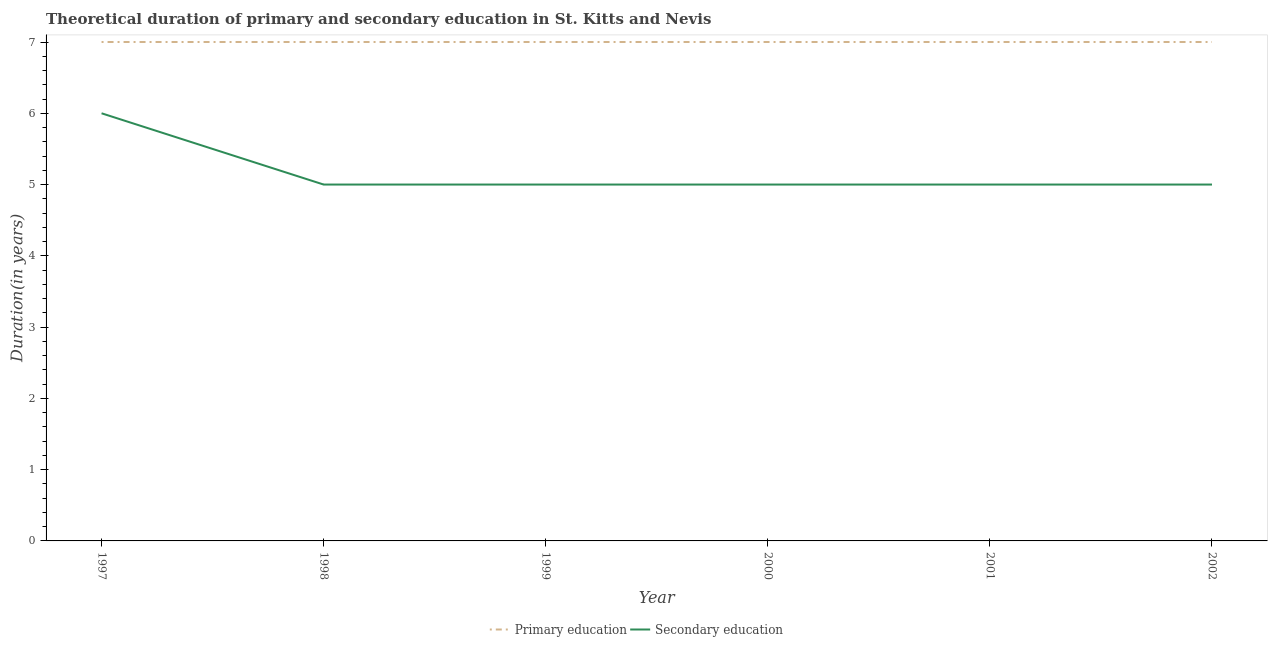Is the number of lines equal to the number of legend labels?
Provide a short and direct response. Yes. What is the duration of primary education in 1998?
Your answer should be compact. 7. Across all years, what is the minimum duration of primary education?
Ensure brevity in your answer.  7. In which year was the duration of primary education maximum?
Your answer should be compact. 1997. In which year was the duration of secondary education minimum?
Keep it short and to the point. 1998. What is the total duration of secondary education in the graph?
Provide a succinct answer. 31. What is the difference between the duration of secondary education in 1997 and that in 2001?
Your response must be concise. 1. What is the difference between the duration of primary education in 2001 and the duration of secondary education in 1999?
Your answer should be compact. 2. What is the average duration of primary education per year?
Provide a succinct answer. 7. In the year 2002, what is the difference between the duration of secondary education and duration of primary education?
Make the answer very short. -2. What is the ratio of the duration of primary education in 1999 to that in 2001?
Make the answer very short. 1. Is the difference between the duration of primary education in 1997 and 1999 greater than the difference between the duration of secondary education in 1997 and 1999?
Your response must be concise. No. What is the difference between the highest and the lowest duration of secondary education?
Offer a very short reply. 1. In how many years, is the duration of primary education greater than the average duration of primary education taken over all years?
Provide a succinct answer. 0. Does the duration of secondary education monotonically increase over the years?
Your answer should be compact. No. Is the duration of secondary education strictly greater than the duration of primary education over the years?
Ensure brevity in your answer.  No. Is the duration of primary education strictly less than the duration of secondary education over the years?
Give a very brief answer. No. How many years are there in the graph?
Make the answer very short. 6. What is the difference between two consecutive major ticks on the Y-axis?
Your answer should be very brief. 1. Are the values on the major ticks of Y-axis written in scientific E-notation?
Give a very brief answer. No. Does the graph contain any zero values?
Provide a succinct answer. No. Does the graph contain grids?
Keep it short and to the point. No. Where does the legend appear in the graph?
Give a very brief answer. Bottom center. How many legend labels are there?
Provide a short and direct response. 2. What is the title of the graph?
Provide a succinct answer. Theoretical duration of primary and secondary education in St. Kitts and Nevis. Does "Canada" appear as one of the legend labels in the graph?
Your answer should be very brief. No. What is the label or title of the Y-axis?
Ensure brevity in your answer.  Duration(in years). What is the Duration(in years) in Primary education in 1997?
Give a very brief answer. 7. What is the Duration(in years) in Primary education in 1998?
Make the answer very short. 7. What is the Duration(in years) of Secondary education in 1999?
Offer a terse response. 5. What is the Duration(in years) of Primary education in 2000?
Make the answer very short. 7. What is the Duration(in years) in Secondary education in 2000?
Ensure brevity in your answer.  5. What is the Duration(in years) in Secondary education in 2001?
Make the answer very short. 5. What is the Duration(in years) in Primary education in 2002?
Your response must be concise. 7. Across all years, what is the maximum Duration(in years) of Primary education?
Offer a terse response. 7. Across all years, what is the maximum Duration(in years) of Secondary education?
Make the answer very short. 6. Across all years, what is the minimum Duration(in years) in Primary education?
Give a very brief answer. 7. What is the total Duration(in years) in Primary education in the graph?
Ensure brevity in your answer.  42. What is the difference between the Duration(in years) of Primary education in 1997 and that in 1998?
Give a very brief answer. 0. What is the difference between the Duration(in years) in Secondary education in 1997 and that in 1998?
Give a very brief answer. 1. What is the difference between the Duration(in years) of Secondary education in 1997 and that in 1999?
Your answer should be very brief. 1. What is the difference between the Duration(in years) of Primary education in 1997 and that in 2000?
Provide a short and direct response. 0. What is the difference between the Duration(in years) in Secondary education in 1997 and that in 2001?
Your response must be concise. 1. What is the difference between the Duration(in years) of Primary education in 1997 and that in 2002?
Make the answer very short. 0. What is the difference between the Duration(in years) of Secondary education in 1997 and that in 2002?
Make the answer very short. 1. What is the difference between the Duration(in years) in Primary education in 1998 and that in 1999?
Offer a terse response. 0. What is the difference between the Duration(in years) of Primary education in 1998 and that in 2000?
Keep it short and to the point. 0. What is the difference between the Duration(in years) of Secondary education in 1998 and that in 2000?
Keep it short and to the point. 0. What is the difference between the Duration(in years) in Secondary education in 1999 and that in 2000?
Give a very brief answer. 0. What is the difference between the Duration(in years) of Secondary education in 1999 and that in 2001?
Provide a succinct answer. 0. What is the difference between the Duration(in years) in Primary education in 1999 and that in 2002?
Keep it short and to the point. 0. What is the difference between the Duration(in years) in Secondary education in 1999 and that in 2002?
Make the answer very short. 0. What is the difference between the Duration(in years) in Secondary education in 2000 and that in 2002?
Your answer should be very brief. 0. What is the difference between the Duration(in years) of Primary education in 2001 and that in 2002?
Provide a succinct answer. 0. What is the difference between the Duration(in years) of Secondary education in 2001 and that in 2002?
Keep it short and to the point. 0. What is the difference between the Duration(in years) in Primary education in 1997 and the Duration(in years) in Secondary education in 1999?
Provide a short and direct response. 2. What is the difference between the Duration(in years) of Primary education in 1997 and the Duration(in years) of Secondary education in 2000?
Provide a short and direct response. 2. What is the difference between the Duration(in years) in Primary education in 1998 and the Duration(in years) in Secondary education in 1999?
Offer a terse response. 2. What is the difference between the Duration(in years) of Primary education in 1998 and the Duration(in years) of Secondary education in 2001?
Make the answer very short. 2. What is the difference between the Duration(in years) in Primary education in 1998 and the Duration(in years) in Secondary education in 2002?
Your answer should be very brief. 2. What is the difference between the Duration(in years) in Primary education in 1999 and the Duration(in years) in Secondary education in 2000?
Keep it short and to the point. 2. What is the difference between the Duration(in years) of Primary education in 1999 and the Duration(in years) of Secondary education in 2001?
Offer a very short reply. 2. What is the difference between the Duration(in years) in Primary education in 2001 and the Duration(in years) in Secondary education in 2002?
Give a very brief answer. 2. What is the average Duration(in years) of Primary education per year?
Provide a succinct answer. 7. What is the average Duration(in years) of Secondary education per year?
Your answer should be compact. 5.17. In the year 1997, what is the difference between the Duration(in years) of Primary education and Duration(in years) of Secondary education?
Ensure brevity in your answer.  1. In the year 1998, what is the difference between the Duration(in years) in Primary education and Duration(in years) in Secondary education?
Keep it short and to the point. 2. In the year 1999, what is the difference between the Duration(in years) of Primary education and Duration(in years) of Secondary education?
Make the answer very short. 2. In the year 2002, what is the difference between the Duration(in years) in Primary education and Duration(in years) in Secondary education?
Offer a very short reply. 2. What is the ratio of the Duration(in years) of Primary education in 1997 to that in 1999?
Your answer should be very brief. 1. What is the ratio of the Duration(in years) of Primary education in 1997 to that in 2000?
Your response must be concise. 1. What is the ratio of the Duration(in years) in Secondary education in 1997 to that in 2000?
Keep it short and to the point. 1.2. What is the ratio of the Duration(in years) in Secondary education in 1997 to that in 2001?
Give a very brief answer. 1.2. What is the ratio of the Duration(in years) in Primary education in 1997 to that in 2002?
Your answer should be compact. 1. What is the ratio of the Duration(in years) in Secondary education in 1998 to that in 2002?
Your answer should be very brief. 1. What is the ratio of the Duration(in years) of Primary education in 1999 to that in 2001?
Ensure brevity in your answer.  1. What is the ratio of the Duration(in years) of Primary education in 2000 to that in 2001?
Keep it short and to the point. 1. What is the ratio of the Duration(in years) in Secondary education in 2000 to that in 2001?
Provide a succinct answer. 1. What is the difference between the highest and the second highest Duration(in years) in Secondary education?
Your response must be concise. 1. What is the difference between the highest and the lowest Duration(in years) of Primary education?
Your answer should be compact. 0. What is the difference between the highest and the lowest Duration(in years) of Secondary education?
Provide a short and direct response. 1. 